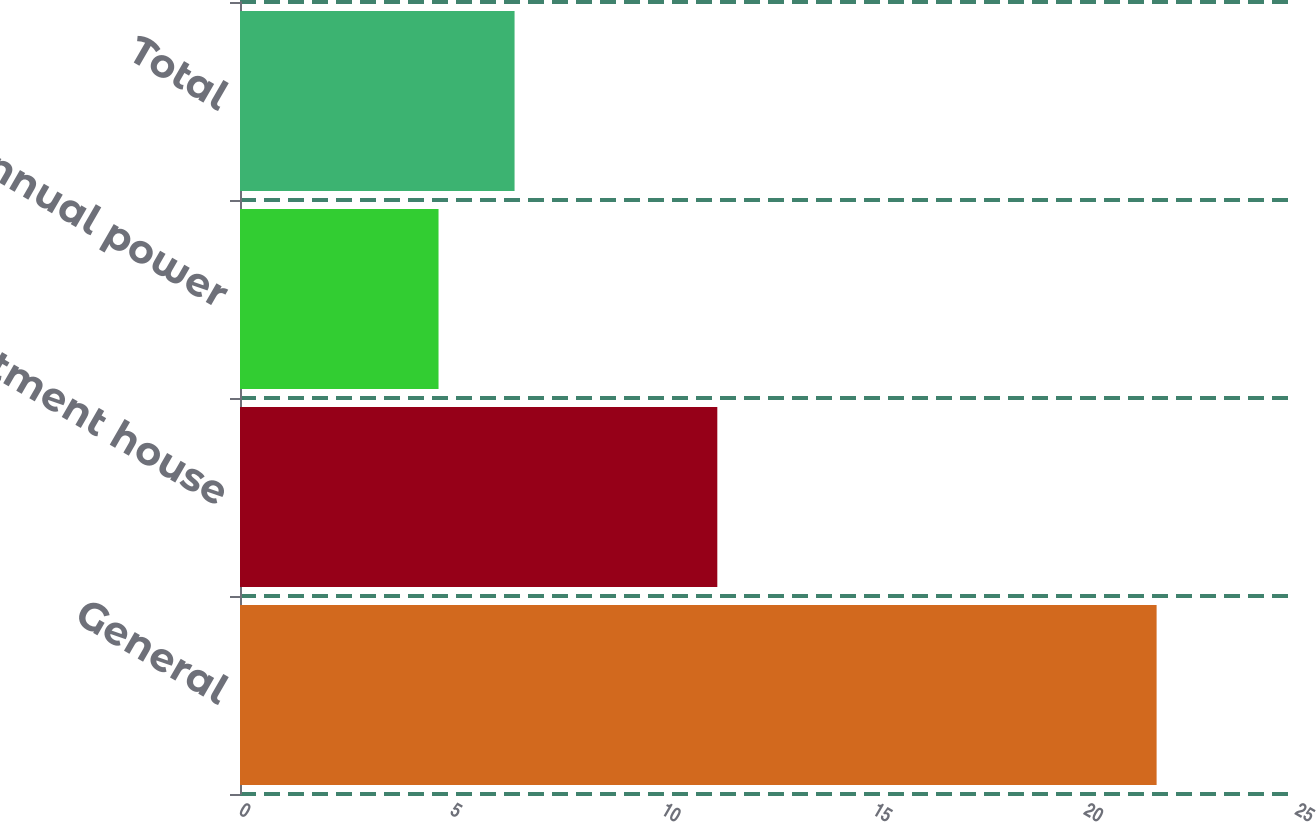Convert chart. <chart><loc_0><loc_0><loc_500><loc_500><bar_chart><fcel>General<fcel>Apartment house<fcel>Annual power<fcel>Total<nl><fcel>21.7<fcel>11.3<fcel>4.7<fcel>6.5<nl></chart> 